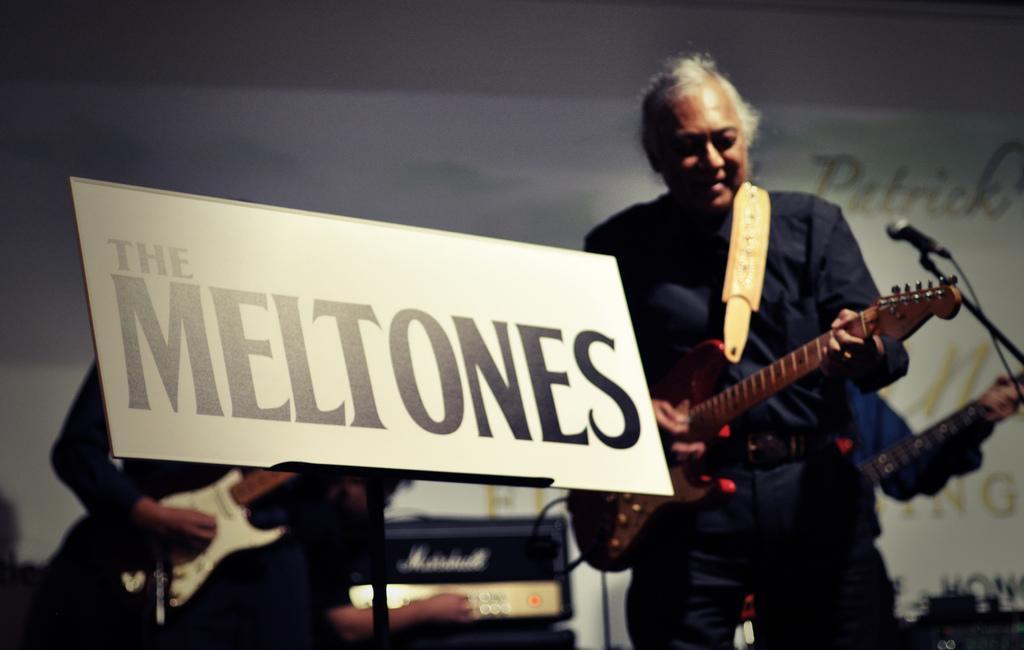How would you summarize this image in a sentence or two? In the center we can see two persons were holding guitar. Here we can see the board written as "The Mel tones". And front we can see microphone,back we can see banner. 